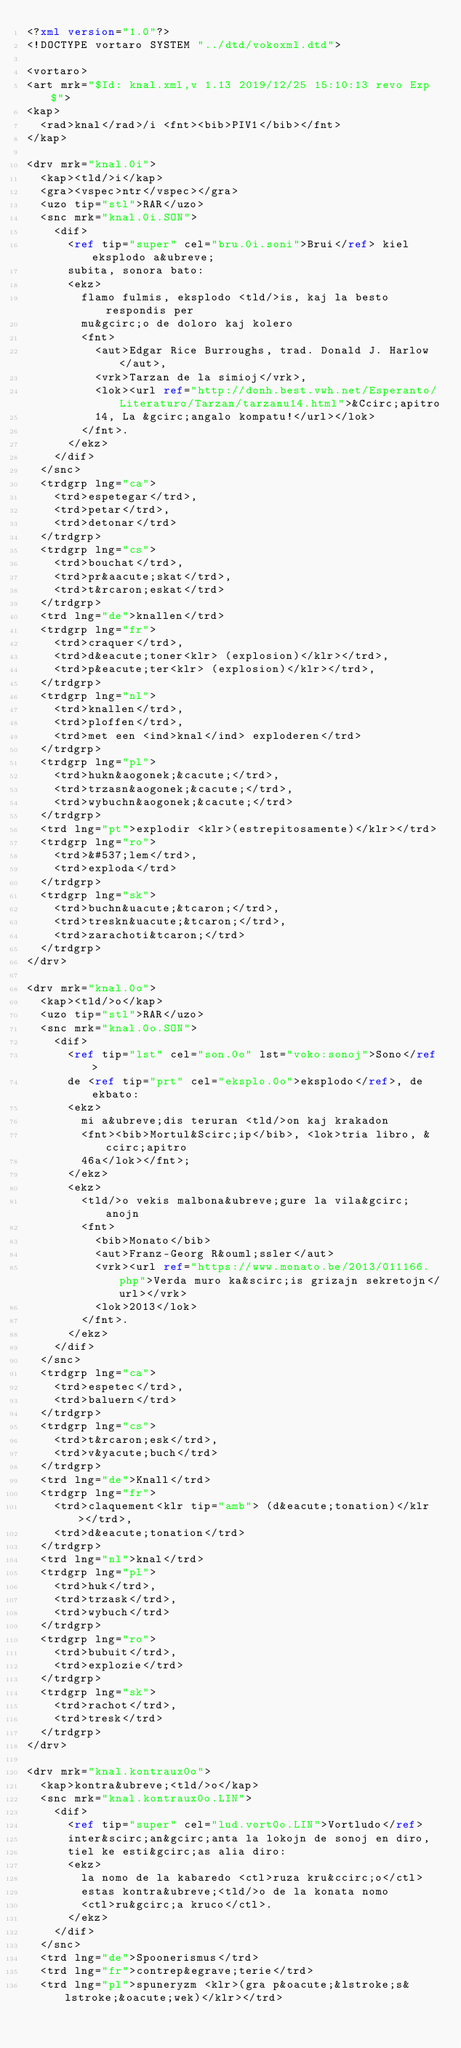Convert code to text. <code><loc_0><loc_0><loc_500><loc_500><_XML_><?xml version="1.0"?>
<!DOCTYPE vortaro SYSTEM "../dtd/vokoxml.dtd">

<vortaro>
<art mrk="$Id: knal.xml,v 1.13 2019/12/25 15:10:13 revo Exp $">
<kap>
  <rad>knal</rad>/i <fnt><bib>PIV1</bib></fnt>
</kap>

<drv mrk="knal.0i">
  <kap><tld/>i</kap>
  <gra><vspec>ntr</vspec></gra>
  <uzo tip="stl">RAR</uzo>
  <snc mrk="knal.0i.SON">
    <dif>
      <ref tip="super" cel="bru.0i.soni">Brui</ref> kiel eksplodo a&ubreve;
      subita, sonora bato:
      <ekz>
        flamo fulmis, eksplodo <tld/>is, kaj la besto respondis per
        mu&gcirc;o de doloro kaj kolero
        <fnt>
          <aut>Edgar Rice Burroughs, trad. Donald J. Harlow</aut>,
          <vrk>Tarzan de la simioj</vrk>,
          <lok><url ref="http://donh.best.vwh.net/Esperanto/Literaturo/Tarzan/tarzanu14.html">&Ccirc;apitro
          14, La &gcirc;angalo kompatu!</url></lok>
        </fnt>.
      </ekz>
    </dif>
  </snc>
  <trdgrp lng="ca">
    <trd>espetegar</trd>,
    <trd>petar</trd>,
    <trd>detonar</trd>    
  </trdgrp>
  <trdgrp lng="cs">
    <trd>bouchat</trd>,
    <trd>pr&aacute;skat</trd>,
    <trd>t&rcaron;eskat</trd>
  </trdgrp>
  <trd lng="de">knallen</trd>
  <trdgrp lng="fr">
    <trd>craquer</trd>,
    <trd>d&eacute;toner<klr> (explosion)</klr></trd>,
    <trd>p&eacute;ter<klr> (explosion)</klr></trd>,
  </trdgrp>
  <trdgrp lng="nl">
    <trd>knallen</trd>,
    <trd>ploffen</trd>,
    <trd>met een <ind>knal</ind> exploderen</trd>
  </trdgrp>
  <trdgrp lng="pl">
    <trd>hukn&aogonek;&cacute;</trd>,
    <trd>trzasn&aogonek;&cacute;</trd>,
    <trd>wybuchn&aogonek;&cacute;</trd>
  </trdgrp> 
  <trd lng="pt">explodir <klr>(estrepitosamente)</klr></trd>
  <trdgrp lng="ro">
    <trd>&#537;lem</trd>,
    <trd>exploda</trd>
  </trdgrp>
  <trdgrp lng="sk">
    <trd>buchn&uacute;&tcaron;</trd>,
    <trd>treskn&uacute;&tcaron;</trd>,
    <trd>zarachoti&tcaron;</trd>
  </trdgrp>
</drv>

<drv mrk="knal.0o">
  <kap><tld/>o</kap>
  <uzo tip="stl">RAR</uzo>
  <snc mrk="knal.0o.SON">
    <dif>
      <ref tip="lst" cel="son.0o" lst="voko:sonoj">Sono</ref> 
      de <ref tip="prt" cel="eksplo.0o">eksplodo</ref>, de ekbato:
      <ekz>
        mi a&ubreve;dis teruran <tld/>on kaj krakadon
        <fnt><bib>Mortul&Scirc;ip</bib>, <lok>tria libro, &ccirc;apitro
        46a</lok></fnt>;
      </ekz>
      <ekz>
        <tld/>o vekis malbona&ubreve;gure la vila&gcirc;anojn
        <fnt>
          <bib>Monato</bib>
          <aut>Franz-Georg R&ouml;ssler</aut>
          <vrk><url ref="https://www.monato.be/2013/011166.php">Verda muro ka&scirc;is grizajn sekretojn</url></vrk>
          <lok>2013</lok>
        </fnt>.
      </ekz>
    </dif>
  </snc>
  <trdgrp lng="ca">
    <trd>espetec</trd>,
    <trd>baluern</trd>
  </trdgrp>
  <trdgrp lng="cs">
    <trd>t&rcaron;esk</trd>,
    <trd>v&yacute;buch</trd>
  </trdgrp>
  <trd lng="de">Knall</trd>
  <trdgrp lng="fr">
    <trd>claquement<klr tip="amb"> (d&eacute;tonation)</klr></trd>,
    <trd>d&eacute;tonation</trd>
  </trdgrp>
  <trd lng="nl">knal</trd>
  <trdgrp lng="pl">
    <trd>huk</trd>,
    <trd>trzask</trd>,
    <trd>wybuch</trd>
  </trdgrp> 
  <trdgrp lng="ro">
    <trd>bubuit</trd>,
    <trd>explozie</trd>
  </trdgrp>
  <trdgrp lng="sk">
    <trd>rachot</trd>,
    <trd>tresk</trd>
  </trdgrp>
</drv>

<drv mrk="knal.kontraux0o">
  <kap>kontra&ubreve;<tld/>o</kap>
  <snc mrk="knal.kontraux0o.LIN">
    <dif>
      <ref tip="super" cel="lud.vort0o.LIN">Vortludo</ref>
      inter&scirc;an&gcirc;anta la lokojn de sonoj en diro,
      tiel ke esti&gcirc;as alia diro:
      <ekz>
        la nomo de la kabaredo <ctl>ruza kru&ccirc;o</ctl>
        estas kontra&ubreve;<tld/>o de la konata nomo
        <ctl>ru&gcirc;a kruco</ctl>.
      </ekz>
    </dif>
  </snc>
  <trd lng="de">Spoonerismus</trd>
  <trd lng="fr">contrep&egrave;terie</trd>
  <trd lng="pl">spuneryzm <klr>(gra p&oacute;&lstroke;s&lstroke;&oacute;wek)</klr></trd>     </code> 